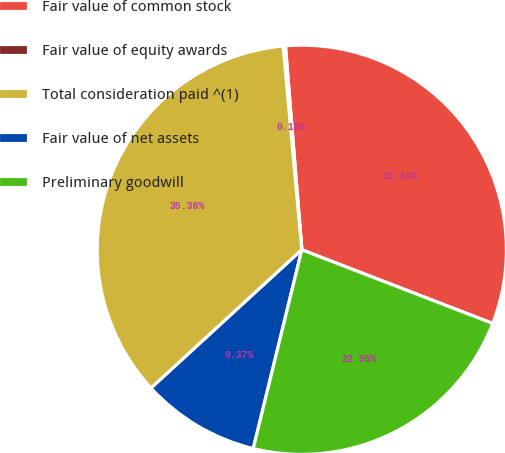Convert chart. <chart><loc_0><loc_0><loc_500><loc_500><pie_chart><fcel>Fair value of common stock<fcel>Fair value of equity awards<fcel>Total consideration paid ^(1)<fcel>Fair value of net assets<fcel>Preliminary goodwill<nl><fcel>32.14%<fcel>0.18%<fcel>35.36%<fcel>9.37%<fcel>22.95%<nl></chart> 